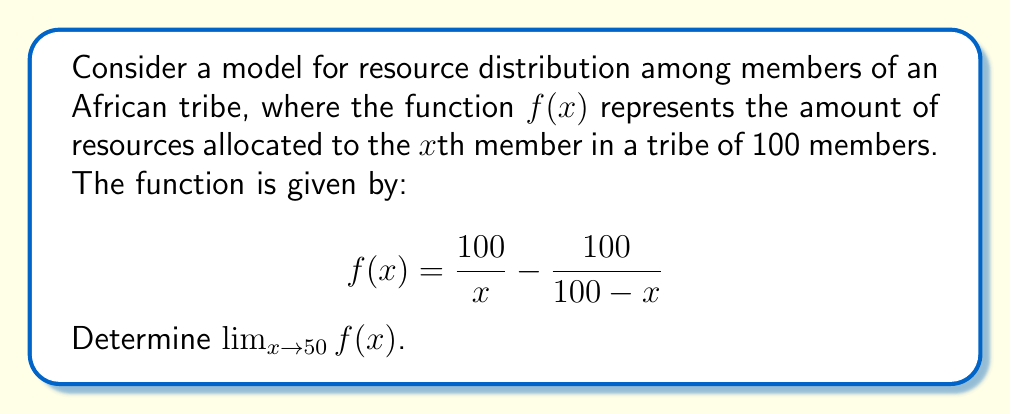Could you help me with this problem? To solve this problem, we'll follow these steps:

1) First, let's analyze the function:
   $$f(x) = \frac{100}{x} - \frac{100}{100-x}$$

2) As $x$ approaches 50, both denominators approach 50. However, we can't simply substitute 50 for $x$, as this would lead to division by zero in the second term.

3) To find the limit, we can use the algebraic method:
   
   $$\lim_{x \to 50} f(x) = \lim_{x \to 50} \left(\frac{100}{x} - \frac{100}{100-x}\right)$$

4) Multiply both terms by $\frac{x(100-x)}{x(100-x)}$:
   
   $$\lim_{x \to 50} \frac{100(100-x) - 100x}{x(100-x)}$$

5) Simplify the numerator:
   
   $$\lim_{x \to 50} \frac{10000 - 200x}{x(100-x)}$$

6) Factor out -200 from the numerator:
   
   $$\lim_{x \to 50} \frac{-200(x-50)}{x(100-x)}$$

7) Factor $(x-50)$ from the denominator:
   
   $$\lim_{x \to 50} \frac{-200}{x+50}$$

8) Now we can safely substitute 50 for $x$:
   
   $$\frac{-200}{50+50} = \frac{-200}{100} = -2$$

This result indicates that as the resource distribution approaches the middle member of the tribe (50th member), the rate of change in resource allocation converges to -2.
Answer: $\lim_{x \to 50} f(x) = -2$ 